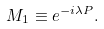Convert formula to latex. <formula><loc_0><loc_0><loc_500><loc_500>M _ { 1 } \equiv e ^ { - i \lambda P } .</formula> 